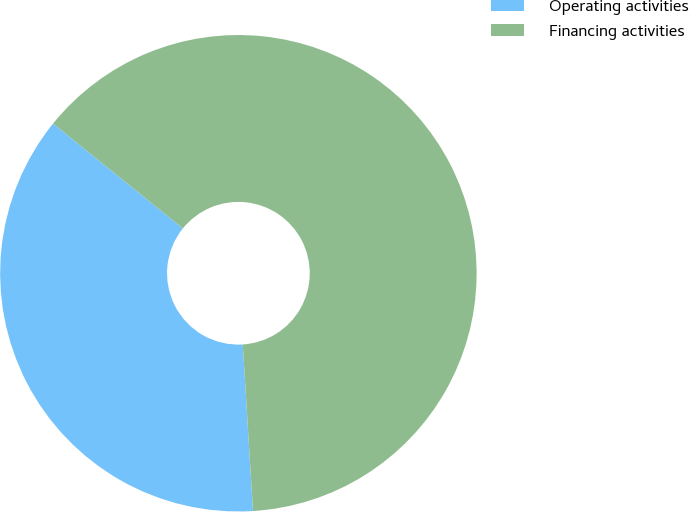Convert chart. <chart><loc_0><loc_0><loc_500><loc_500><pie_chart><fcel>Operating activities<fcel>Financing activities<nl><fcel>36.79%<fcel>63.21%<nl></chart> 